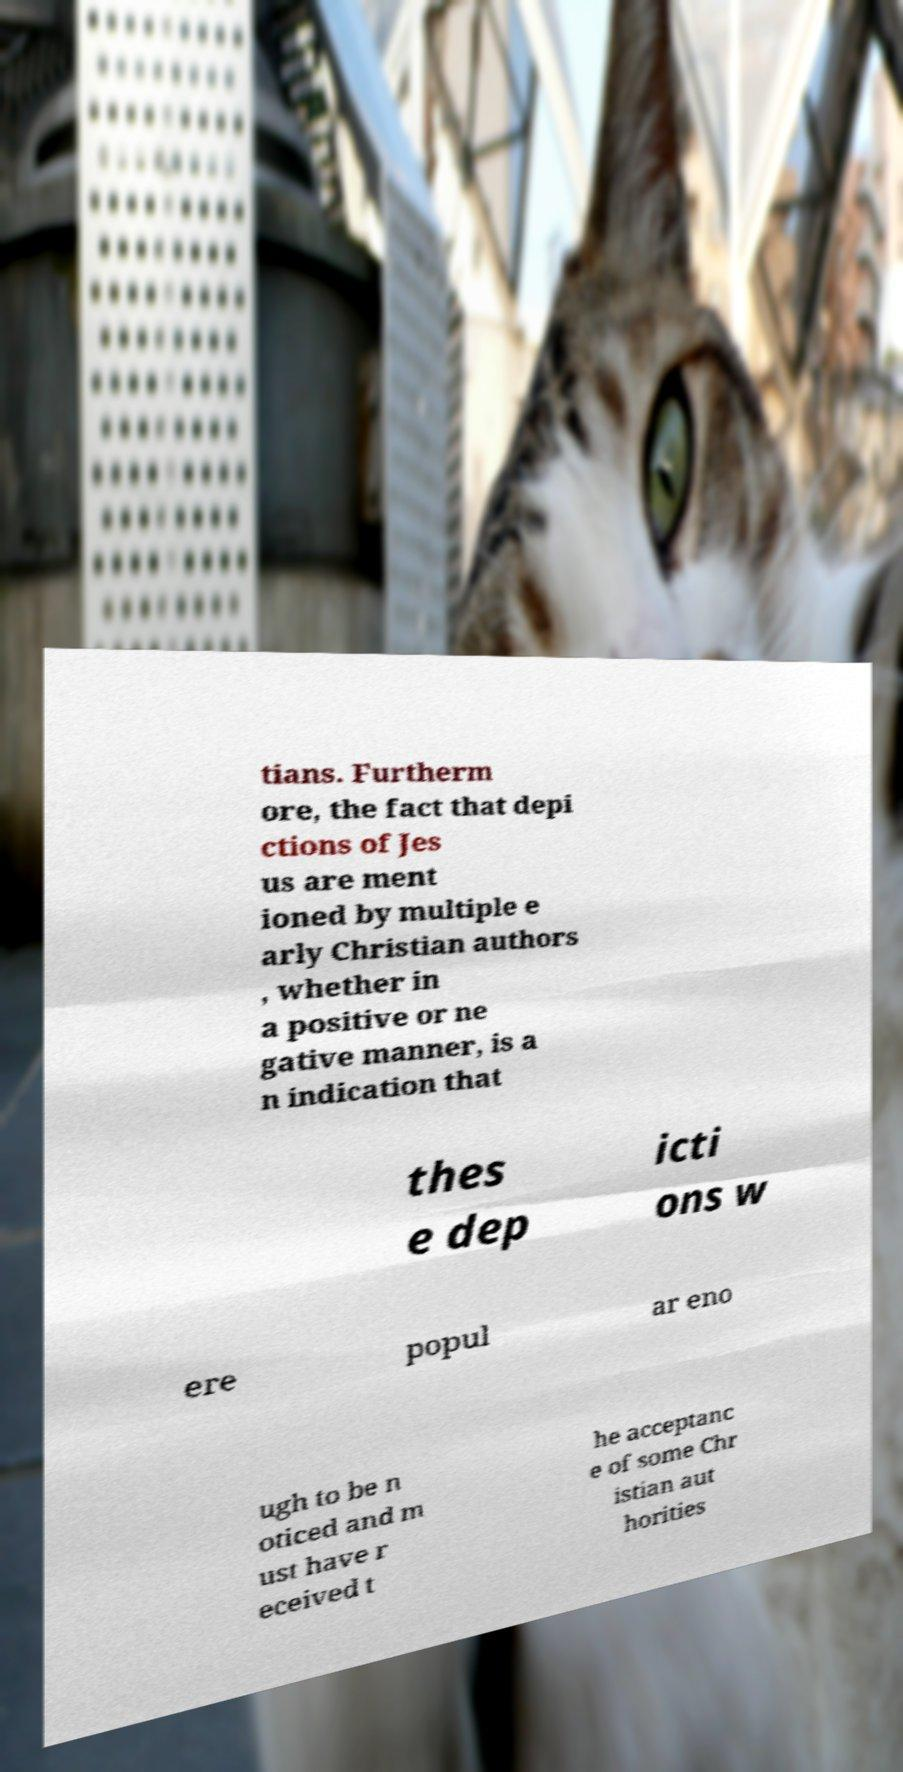Please read and relay the text visible in this image. What does it say? tians. Furtherm ore, the fact that depi ctions of Jes us are ment ioned by multiple e arly Christian authors , whether in a positive or ne gative manner, is a n indication that thes e dep icti ons w ere popul ar eno ugh to be n oticed and m ust have r eceived t he acceptanc e of some Chr istian aut horities 